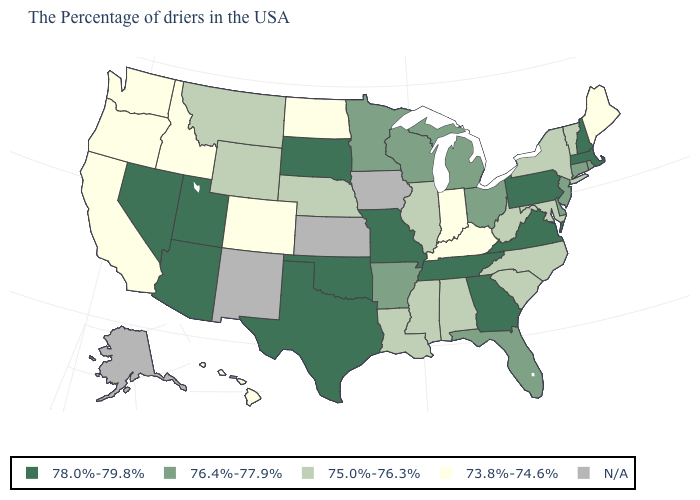What is the lowest value in the USA?
Be succinct. 73.8%-74.6%. What is the value of Vermont?
Give a very brief answer. 75.0%-76.3%. Is the legend a continuous bar?
Keep it brief. No. Name the states that have a value in the range N/A?
Quick response, please. Iowa, Kansas, New Mexico, Alaska. Name the states that have a value in the range 78.0%-79.8%?
Short answer required. Massachusetts, New Hampshire, Pennsylvania, Virginia, Georgia, Tennessee, Missouri, Oklahoma, Texas, South Dakota, Utah, Arizona, Nevada. What is the lowest value in the Northeast?
Quick response, please. 73.8%-74.6%. Name the states that have a value in the range 73.8%-74.6%?
Concise answer only. Maine, Kentucky, Indiana, North Dakota, Colorado, Idaho, California, Washington, Oregon, Hawaii. Is the legend a continuous bar?
Answer briefly. No. What is the value of Oregon?
Answer briefly. 73.8%-74.6%. What is the value of Minnesota?
Be succinct. 76.4%-77.9%. What is the value of North Dakota?
Short answer required. 73.8%-74.6%. What is the highest value in the USA?
Quick response, please. 78.0%-79.8%. Which states have the highest value in the USA?
Concise answer only. Massachusetts, New Hampshire, Pennsylvania, Virginia, Georgia, Tennessee, Missouri, Oklahoma, Texas, South Dakota, Utah, Arizona, Nevada. What is the value of New Jersey?
Give a very brief answer. 76.4%-77.9%. 